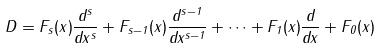Convert formula to latex. <formula><loc_0><loc_0><loc_500><loc_500>D = F _ { s } ( x ) \frac { d ^ { s } } { d x ^ { s } } + F _ { s - 1 } ( x ) \frac { d ^ { s - 1 } } { d x ^ { s - 1 } } + \cdots + F _ { 1 } ( x ) \frac { d } { d x } + F _ { 0 } ( x )</formula> 